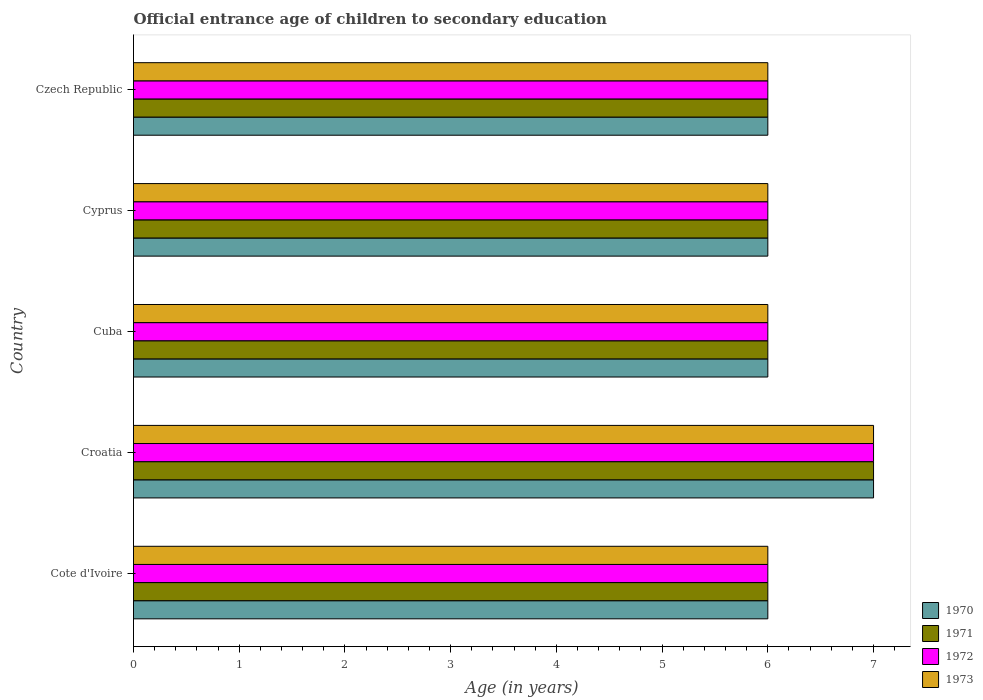How many groups of bars are there?
Your answer should be very brief. 5. Are the number of bars on each tick of the Y-axis equal?
Ensure brevity in your answer.  Yes. How many bars are there on the 1st tick from the bottom?
Your answer should be very brief. 4. What is the label of the 1st group of bars from the top?
Provide a succinct answer. Czech Republic. What is the secondary school starting age of children in 1971 in Cote d'Ivoire?
Offer a very short reply. 6. Across all countries, what is the maximum secondary school starting age of children in 1973?
Ensure brevity in your answer.  7. Across all countries, what is the minimum secondary school starting age of children in 1971?
Offer a very short reply. 6. In which country was the secondary school starting age of children in 1972 maximum?
Offer a terse response. Croatia. In which country was the secondary school starting age of children in 1970 minimum?
Your response must be concise. Cote d'Ivoire. What is the total secondary school starting age of children in 1970 in the graph?
Ensure brevity in your answer.  31. What is the difference between the secondary school starting age of children in 1973 and secondary school starting age of children in 1970 in Croatia?
Your response must be concise. 0. In how many countries, is the secondary school starting age of children in 1970 greater than 2 years?
Offer a very short reply. 5. What is the ratio of the secondary school starting age of children in 1971 in Croatia to that in Czech Republic?
Your answer should be very brief. 1.17. Is the secondary school starting age of children in 1972 in Cuba less than that in Cyprus?
Your response must be concise. No. Is the difference between the secondary school starting age of children in 1973 in Cote d'Ivoire and Croatia greater than the difference between the secondary school starting age of children in 1970 in Cote d'Ivoire and Croatia?
Make the answer very short. No. What is the difference between the highest and the second highest secondary school starting age of children in 1971?
Keep it short and to the point. 1. What is the difference between the highest and the lowest secondary school starting age of children in 1972?
Offer a terse response. 1. Is the sum of the secondary school starting age of children in 1972 in Cote d'Ivoire and Czech Republic greater than the maximum secondary school starting age of children in 1971 across all countries?
Your answer should be compact. Yes. What does the 1st bar from the bottom in Czech Republic represents?
Your answer should be very brief. 1970. Are all the bars in the graph horizontal?
Ensure brevity in your answer.  Yes. How many countries are there in the graph?
Your answer should be very brief. 5. What is the difference between two consecutive major ticks on the X-axis?
Offer a terse response. 1. Does the graph contain any zero values?
Provide a succinct answer. No. Does the graph contain grids?
Your response must be concise. No. Where does the legend appear in the graph?
Ensure brevity in your answer.  Bottom right. How are the legend labels stacked?
Ensure brevity in your answer.  Vertical. What is the title of the graph?
Make the answer very short. Official entrance age of children to secondary education. Does "1983" appear as one of the legend labels in the graph?
Offer a terse response. No. What is the label or title of the X-axis?
Your answer should be compact. Age (in years). What is the Age (in years) of 1970 in Cote d'Ivoire?
Provide a succinct answer. 6. What is the Age (in years) in 1971 in Cote d'Ivoire?
Offer a terse response. 6. What is the Age (in years) in 1972 in Cote d'Ivoire?
Your response must be concise. 6. What is the Age (in years) of 1973 in Cote d'Ivoire?
Ensure brevity in your answer.  6. What is the Age (in years) in 1970 in Croatia?
Offer a very short reply. 7. What is the Age (in years) in 1971 in Croatia?
Your answer should be compact. 7. What is the Age (in years) in 1972 in Croatia?
Keep it short and to the point. 7. What is the Age (in years) in 1970 in Cuba?
Give a very brief answer. 6. What is the Age (in years) of 1971 in Cuba?
Offer a terse response. 6. What is the Age (in years) in 1972 in Cuba?
Provide a short and direct response. 6. What is the Age (in years) in 1970 in Cyprus?
Provide a short and direct response. 6. What is the Age (in years) of 1972 in Cyprus?
Keep it short and to the point. 6. What is the Age (in years) of 1970 in Czech Republic?
Provide a succinct answer. 6. Across all countries, what is the maximum Age (in years) of 1970?
Provide a succinct answer. 7. Across all countries, what is the maximum Age (in years) in 1971?
Your answer should be very brief. 7. Across all countries, what is the maximum Age (in years) in 1972?
Provide a succinct answer. 7. Across all countries, what is the minimum Age (in years) of 1970?
Your answer should be very brief. 6. Across all countries, what is the minimum Age (in years) in 1973?
Offer a very short reply. 6. What is the total Age (in years) in 1970 in the graph?
Provide a succinct answer. 31. What is the total Age (in years) in 1972 in the graph?
Keep it short and to the point. 31. What is the difference between the Age (in years) of 1970 in Cote d'Ivoire and that in Croatia?
Offer a terse response. -1. What is the difference between the Age (in years) of 1972 in Cote d'Ivoire and that in Croatia?
Make the answer very short. -1. What is the difference between the Age (in years) of 1973 in Cote d'Ivoire and that in Croatia?
Give a very brief answer. -1. What is the difference between the Age (in years) of 1970 in Cote d'Ivoire and that in Cuba?
Ensure brevity in your answer.  0. What is the difference between the Age (in years) in 1972 in Cote d'Ivoire and that in Cuba?
Provide a short and direct response. 0. What is the difference between the Age (in years) in 1973 in Cote d'Ivoire and that in Cuba?
Your response must be concise. 0. What is the difference between the Age (in years) in 1973 in Cote d'Ivoire and that in Cyprus?
Provide a succinct answer. 0. What is the difference between the Age (in years) in 1970 in Cote d'Ivoire and that in Czech Republic?
Ensure brevity in your answer.  0. What is the difference between the Age (in years) in 1973 in Cote d'Ivoire and that in Czech Republic?
Provide a short and direct response. 0. What is the difference between the Age (in years) of 1972 in Croatia and that in Cuba?
Give a very brief answer. 1. What is the difference between the Age (in years) of 1970 in Croatia and that in Cyprus?
Provide a succinct answer. 1. What is the difference between the Age (in years) of 1970 in Croatia and that in Czech Republic?
Provide a short and direct response. 1. What is the difference between the Age (in years) in 1971 in Croatia and that in Czech Republic?
Offer a very short reply. 1. What is the difference between the Age (in years) of 1973 in Croatia and that in Czech Republic?
Your response must be concise. 1. What is the difference between the Age (in years) in 1971 in Cuba and that in Cyprus?
Provide a succinct answer. 0. What is the difference between the Age (in years) of 1973 in Cuba and that in Cyprus?
Offer a very short reply. 0. What is the difference between the Age (in years) in 1970 in Cuba and that in Czech Republic?
Offer a terse response. 0. What is the difference between the Age (in years) in 1970 in Cyprus and that in Czech Republic?
Your answer should be compact. 0. What is the difference between the Age (in years) of 1972 in Cyprus and that in Czech Republic?
Your response must be concise. 0. What is the difference between the Age (in years) in 1973 in Cyprus and that in Czech Republic?
Give a very brief answer. 0. What is the difference between the Age (in years) in 1970 in Cote d'Ivoire and the Age (in years) in 1971 in Croatia?
Ensure brevity in your answer.  -1. What is the difference between the Age (in years) in 1970 in Cote d'Ivoire and the Age (in years) in 1972 in Croatia?
Provide a succinct answer. -1. What is the difference between the Age (in years) in 1970 in Cote d'Ivoire and the Age (in years) in 1971 in Cuba?
Offer a terse response. 0. What is the difference between the Age (in years) in 1970 in Cote d'Ivoire and the Age (in years) in 1973 in Cuba?
Keep it short and to the point. 0. What is the difference between the Age (in years) of 1971 in Cote d'Ivoire and the Age (in years) of 1973 in Cuba?
Provide a succinct answer. 0. What is the difference between the Age (in years) of 1970 in Cote d'Ivoire and the Age (in years) of 1971 in Cyprus?
Provide a short and direct response. 0. What is the difference between the Age (in years) of 1970 in Cote d'Ivoire and the Age (in years) of 1972 in Cyprus?
Offer a terse response. 0. What is the difference between the Age (in years) of 1970 in Cote d'Ivoire and the Age (in years) of 1973 in Cyprus?
Make the answer very short. 0. What is the difference between the Age (in years) in 1971 in Cote d'Ivoire and the Age (in years) in 1972 in Cyprus?
Your answer should be compact. 0. What is the difference between the Age (in years) of 1971 in Cote d'Ivoire and the Age (in years) of 1973 in Cyprus?
Ensure brevity in your answer.  0. What is the difference between the Age (in years) of 1970 in Cote d'Ivoire and the Age (in years) of 1971 in Czech Republic?
Your response must be concise. 0. What is the difference between the Age (in years) of 1970 in Cote d'Ivoire and the Age (in years) of 1972 in Czech Republic?
Offer a very short reply. 0. What is the difference between the Age (in years) in 1970 in Cote d'Ivoire and the Age (in years) in 1973 in Czech Republic?
Your answer should be very brief. 0. What is the difference between the Age (in years) of 1971 in Cote d'Ivoire and the Age (in years) of 1972 in Czech Republic?
Make the answer very short. 0. What is the difference between the Age (in years) in 1972 in Cote d'Ivoire and the Age (in years) in 1973 in Czech Republic?
Give a very brief answer. 0. What is the difference between the Age (in years) of 1971 in Croatia and the Age (in years) of 1973 in Cuba?
Provide a short and direct response. 1. What is the difference between the Age (in years) of 1972 in Croatia and the Age (in years) of 1973 in Cuba?
Provide a succinct answer. 1. What is the difference between the Age (in years) of 1970 in Croatia and the Age (in years) of 1971 in Cyprus?
Your answer should be very brief. 1. What is the difference between the Age (in years) in 1970 in Croatia and the Age (in years) in 1972 in Cyprus?
Give a very brief answer. 1. What is the difference between the Age (in years) of 1970 in Croatia and the Age (in years) of 1973 in Cyprus?
Offer a terse response. 1. What is the difference between the Age (in years) in 1971 in Croatia and the Age (in years) in 1973 in Cyprus?
Keep it short and to the point. 1. What is the difference between the Age (in years) of 1972 in Croatia and the Age (in years) of 1973 in Cyprus?
Ensure brevity in your answer.  1. What is the difference between the Age (in years) of 1970 in Croatia and the Age (in years) of 1972 in Czech Republic?
Provide a short and direct response. 1. What is the difference between the Age (in years) in 1972 in Croatia and the Age (in years) in 1973 in Czech Republic?
Ensure brevity in your answer.  1. What is the difference between the Age (in years) of 1970 in Cuba and the Age (in years) of 1973 in Cyprus?
Provide a short and direct response. 0. What is the difference between the Age (in years) of 1971 in Cuba and the Age (in years) of 1972 in Cyprus?
Keep it short and to the point. 0. What is the difference between the Age (in years) of 1971 in Cuba and the Age (in years) of 1973 in Cyprus?
Ensure brevity in your answer.  0. What is the difference between the Age (in years) of 1972 in Cuba and the Age (in years) of 1973 in Cyprus?
Ensure brevity in your answer.  0. What is the difference between the Age (in years) of 1970 in Cuba and the Age (in years) of 1972 in Czech Republic?
Ensure brevity in your answer.  0. What is the difference between the Age (in years) of 1971 in Cuba and the Age (in years) of 1973 in Czech Republic?
Offer a terse response. 0. What is the difference between the Age (in years) in 1970 in Cyprus and the Age (in years) in 1971 in Czech Republic?
Keep it short and to the point. 0. What is the difference between the Age (in years) of 1970 in Cyprus and the Age (in years) of 1972 in Czech Republic?
Keep it short and to the point. 0. What is the difference between the Age (in years) of 1971 in Cyprus and the Age (in years) of 1973 in Czech Republic?
Your answer should be compact. 0. What is the difference between the Age (in years) of 1972 in Cyprus and the Age (in years) of 1973 in Czech Republic?
Provide a succinct answer. 0. What is the average Age (in years) of 1971 per country?
Offer a very short reply. 6.2. What is the average Age (in years) of 1972 per country?
Provide a succinct answer. 6.2. What is the average Age (in years) in 1973 per country?
Provide a succinct answer. 6.2. What is the difference between the Age (in years) in 1970 and Age (in years) in 1971 in Cote d'Ivoire?
Your response must be concise. 0. What is the difference between the Age (in years) of 1971 and Age (in years) of 1972 in Cote d'Ivoire?
Make the answer very short. 0. What is the difference between the Age (in years) of 1971 and Age (in years) of 1973 in Cote d'Ivoire?
Your answer should be compact. 0. What is the difference between the Age (in years) in 1971 and Age (in years) in 1972 in Croatia?
Offer a very short reply. 0. What is the difference between the Age (in years) in 1972 and Age (in years) in 1973 in Croatia?
Give a very brief answer. 0. What is the difference between the Age (in years) of 1970 and Age (in years) of 1973 in Cuba?
Ensure brevity in your answer.  0. What is the difference between the Age (in years) of 1971 and Age (in years) of 1972 in Cuba?
Offer a terse response. 0. What is the difference between the Age (in years) of 1971 and Age (in years) of 1973 in Cuba?
Your answer should be very brief. 0. What is the difference between the Age (in years) in 1972 and Age (in years) in 1973 in Cuba?
Keep it short and to the point. 0. What is the difference between the Age (in years) in 1970 and Age (in years) in 1972 in Cyprus?
Keep it short and to the point. 0. What is the difference between the Age (in years) in 1970 and Age (in years) in 1973 in Cyprus?
Ensure brevity in your answer.  0. What is the difference between the Age (in years) in 1971 and Age (in years) in 1972 in Cyprus?
Give a very brief answer. 0. What is the difference between the Age (in years) of 1970 and Age (in years) of 1971 in Czech Republic?
Give a very brief answer. 0. What is the difference between the Age (in years) in 1970 and Age (in years) in 1973 in Czech Republic?
Offer a very short reply. 0. What is the difference between the Age (in years) of 1971 and Age (in years) of 1973 in Czech Republic?
Offer a very short reply. 0. What is the ratio of the Age (in years) of 1970 in Cote d'Ivoire to that in Croatia?
Give a very brief answer. 0.86. What is the ratio of the Age (in years) in 1972 in Cote d'Ivoire to that in Croatia?
Offer a very short reply. 0.86. What is the ratio of the Age (in years) in 1970 in Cote d'Ivoire to that in Cuba?
Make the answer very short. 1. What is the ratio of the Age (in years) in 1971 in Cote d'Ivoire to that in Cuba?
Your response must be concise. 1. What is the ratio of the Age (in years) of 1970 in Cote d'Ivoire to that in Czech Republic?
Provide a succinct answer. 1. What is the ratio of the Age (in years) of 1972 in Cote d'Ivoire to that in Czech Republic?
Ensure brevity in your answer.  1. What is the ratio of the Age (in years) of 1972 in Croatia to that in Cuba?
Provide a succinct answer. 1.17. What is the ratio of the Age (in years) of 1973 in Croatia to that in Cuba?
Offer a terse response. 1.17. What is the ratio of the Age (in years) in 1970 in Croatia to that in Cyprus?
Your answer should be compact. 1.17. What is the ratio of the Age (in years) of 1971 in Croatia to that in Cyprus?
Your answer should be very brief. 1.17. What is the ratio of the Age (in years) in 1972 in Croatia to that in Cyprus?
Offer a very short reply. 1.17. What is the ratio of the Age (in years) in 1971 in Croatia to that in Czech Republic?
Provide a succinct answer. 1.17. What is the ratio of the Age (in years) in 1970 in Cuba to that in Cyprus?
Your response must be concise. 1. What is the ratio of the Age (in years) of 1971 in Cuba to that in Cyprus?
Keep it short and to the point. 1. What is the ratio of the Age (in years) in 1972 in Cuba to that in Cyprus?
Keep it short and to the point. 1. What is the ratio of the Age (in years) of 1972 in Cuba to that in Czech Republic?
Your response must be concise. 1. What is the ratio of the Age (in years) in 1971 in Cyprus to that in Czech Republic?
Your response must be concise. 1. What is the ratio of the Age (in years) in 1973 in Cyprus to that in Czech Republic?
Your answer should be very brief. 1. What is the difference between the highest and the second highest Age (in years) of 1970?
Offer a very short reply. 1. What is the difference between the highest and the lowest Age (in years) in 1972?
Offer a very short reply. 1. What is the difference between the highest and the lowest Age (in years) of 1973?
Offer a very short reply. 1. 